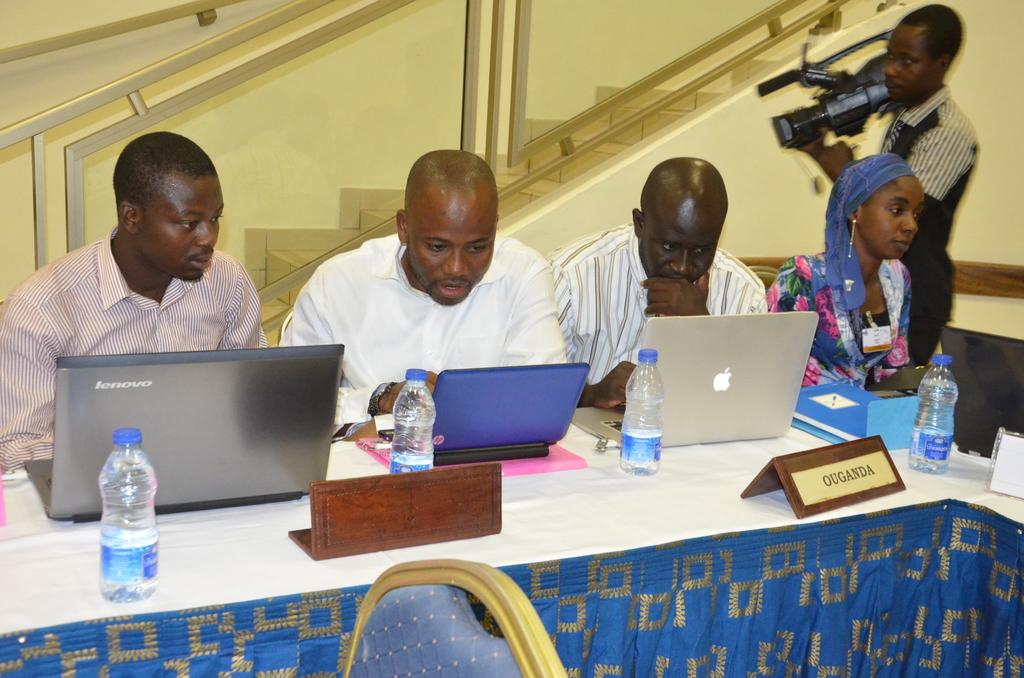What brand is the laptop on the left?
Offer a very short reply. Lenovo. 